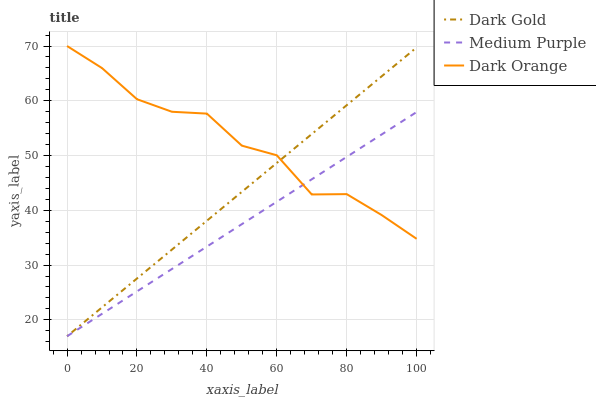Does Dark Gold have the minimum area under the curve?
Answer yes or no. No. Does Dark Gold have the maximum area under the curve?
Answer yes or no. No. Is Dark Gold the smoothest?
Answer yes or no. No. Is Dark Gold the roughest?
Answer yes or no. No. Does Dark Orange have the lowest value?
Answer yes or no. No. Does Dark Gold have the highest value?
Answer yes or no. No. 